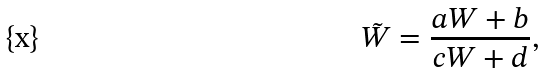<formula> <loc_0><loc_0><loc_500><loc_500>\tilde { W } = \frac { a W + b } { c W + d } ,</formula> 